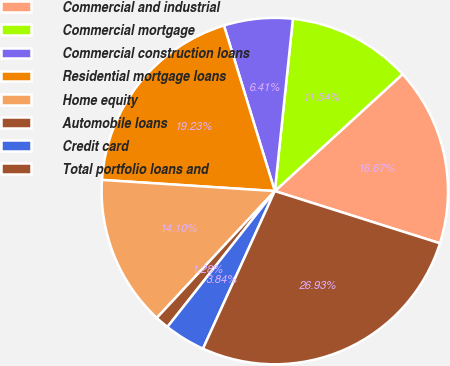Convert chart. <chart><loc_0><loc_0><loc_500><loc_500><pie_chart><fcel>Commercial and industrial<fcel>Commercial mortgage<fcel>Commercial construction loans<fcel>Residential mortgage loans<fcel>Home equity<fcel>Automobile loans<fcel>Credit card<fcel>Total portfolio loans and<nl><fcel>16.67%<fcel>11.54%<fcel>6.41%<fcel>19.23%<fcel>14.1%<fcel>1.28%<fcel>3.84%<fcel>26.93%<nl></chart> 